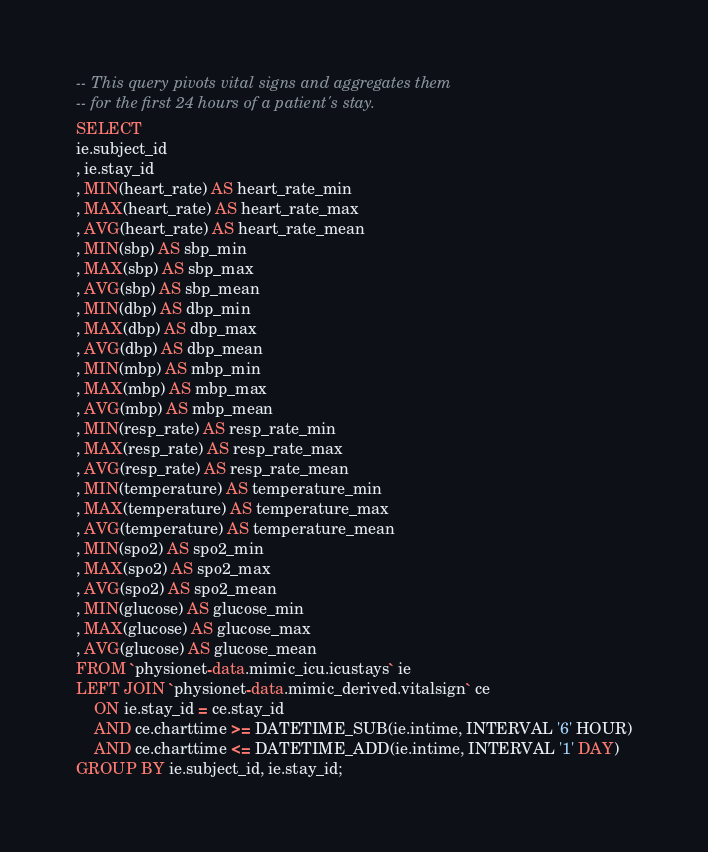<code> <loc_0><loc_0><loc_500><loc_500><_SQL_>-- This query pivots vital signs and aggregates them
-- for the first 24 hours of a patient's stay.
SELECT
ie.subject_id
, ie.stay_id
, MIN(heart_rate) AS heart_rate_min
, MAX(heart_rate) AS heart_rate_max
, AVG(heart_rate) AS heart_rate_mean
, MIN(sbp) AS sbp_min
, MAX(sbp) AS sbp_max
, AVG(sbp) AS sbp_mean
, MIN(dbp) AS dbp_min
, MAX(dbp) AS dbp_max
, AVG(dbp) AS dbp_mean
, MIN(mbp) AS mbp_min
, MAX(mbp) AS mbp_max
, AVG(mbp) AS mbp_mean
, MIN(resp_rate) AS resp_rate_min
, MAX(resp_rate) AS resp_rate_max
, AVG(resp_rate) AS resp_rate_mean
, MIN(temperature) AS temperature_min
, MAX(temperature) AS temperature_max
, AVG(temperature) AS temperature_mean
, MIN(spo2) AS spo2_min
, MAX(spo2) AS spo2_max
, AVG(spo2) AS spo2_mean
, MIN(glucose) AS glucose_min
, MAX(glucose) AS glucose_max
, AVG(glucose) AS glucose_mean
FROM `physionet-data.mimic_icu.icustays` ie
LEFT JOIN `physionet-data.mimic_derived.vitalsign` ce
    ON ie.stay_id = ce.stay_id
    AND ce.charttime >= DATETIME_SUB(ie.intime, INTERVAL '6' HOUR)
    AND ce.charttime <= DATETIME_ADD(ie.intime, INTERVAL '1' DAY)
GROUP BY ie.subject_id, ie.stay_id;</code> 